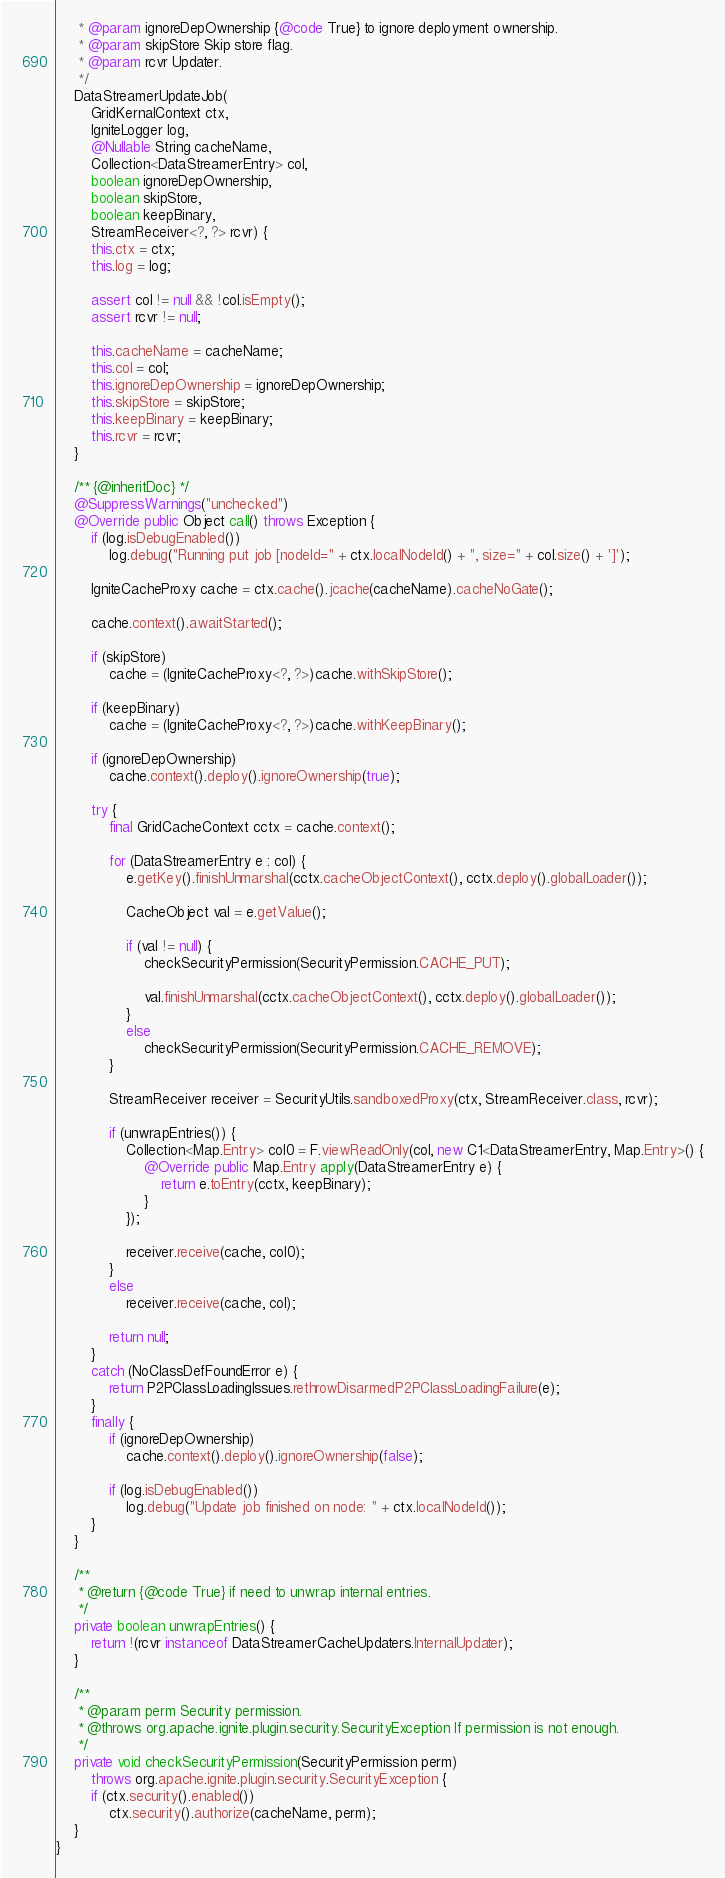Convert code to text. <code><loc_0><loc_0><loc_500><loc_500><_Java_>     * @param ignoreDepOwnership {@code True} to ignore deployment ownership.
     * @param skipStore Skip store flag.
     * @param rcvr Updater.
     */
    DataStreamerUpdateJob(
        GridKernalContext ctx,
        IgniteLogger log,
        @Nullable String cacheName,
        Collection<DataStreamerEntry> col,
        boolean ignoreDepOwnership,
        boolean skipStore,
        boolean keepBinary,
        StreamReceiver<?, ?> rcvr) {
        this.ctx = ctx;
        this.log = log;

        assert col != null && !col.isEmpty();
        assert rcvr != null;

        this.cacheName = cacheName;
        this.col = col;
        this.ignoreDepOwnership = ignoreDepOwnership;
        this.skipStore = skipStore;
        this.keepBinary = keepBinary;
        this.rcvr = rcvr;
    }

    /** {@inheritDoc} */
    @SuppressWarnings("unchecked")
    @Override public Object call() throws Exception {
        if (log.isDebugEnabled())
            log.debug("Running put job [nodeId=" + ctx.localNodeId() + ", size=" + col.size() + ']');

        IgniteCacheProxy cache = ctx.cache().jcache(cacheName).cacheNoGate();

        cache.context().awaitStarted();

        if (skipStore)
            cache = (IgniteCacheProxy<?, ?>)cache.withSkipStore();

        if (keepBinary)
            cache = (IgniteCacheProxy<?, ?>)cache.withKeepBinary();

        if (ignoreDepOwnership)
            cache.context().deploy().ignoreOwnership(true);

        try {
            final GridCacheContext cctx = cache.context();

            for (DataStreamerEntry e : col) {
                e.getKey().finishUnmarshal(cctx.cacheObjectContext(), cctx.deploy().globalLoader());

                CacheObject val = e.getValue();

                if (val != null) {
                    checkSecurityPermission(SecurityPermission.CACHE_PUT);

                    val.finishUnmarshal(cctx.cacheObjectContext(), cctx.deploy().globalLoader());
                }
                else
                    checkSecurityPermission(SecurityPermission.CACHE_REMOVE);
            }

            StreamReceiver receiver = SecurityUtils.sandboxedProxy(ctx, StreamReceiver.class, rcvr);

            if (unwrapEntries()) {
                Collection<Map.Entry> col0 = F.viewReadOnly(col, new C1<DataStreamerEntry, Map.Entry>() {
                    @Override public Map.Entry apply(DataStreamerEntry e) {
                        return e.toEntry(cctx, keepBinary);
                    }
                });

                receiver.receive(cache, col0);
            }
            else
                receiver.receive(cache, col);

            return null;
        }
        catch (NoClassDefFoundError e) {
            return P2PClassLoadingIssues.rethrowDisarmedP2PClassLoadingFailure(e);
        }
        finally {
            if (ignoreDepOwnership)
                cache.context().deploy().ignoreOwnership(false);

            if (log.isDebugEnabled())
                log.debug("Update job finished on node: " + ctx.localNodeId());
        }
    }

    /**
     * @return {@code True} if need to unwrap internal entries.
     */
    private boolean unwrapEntries() {
        return !(rcvr instanceof DataStreamerCacheUpdaters.InternalUpdater);
    }

    /**
     * @param perm Security permission.
     * @throws org.apache.ignite.plugin.security.SecurityException If permission is not enough.
     */
    private void checkSecurityPermission(SecurityPermission perm)
        throws org.apache.ignite.plugin.security.SecurityException {
        if (ctx.security().enabled())
            ctx.security().authorize(cacheName, perm);
    }
}
</code> 